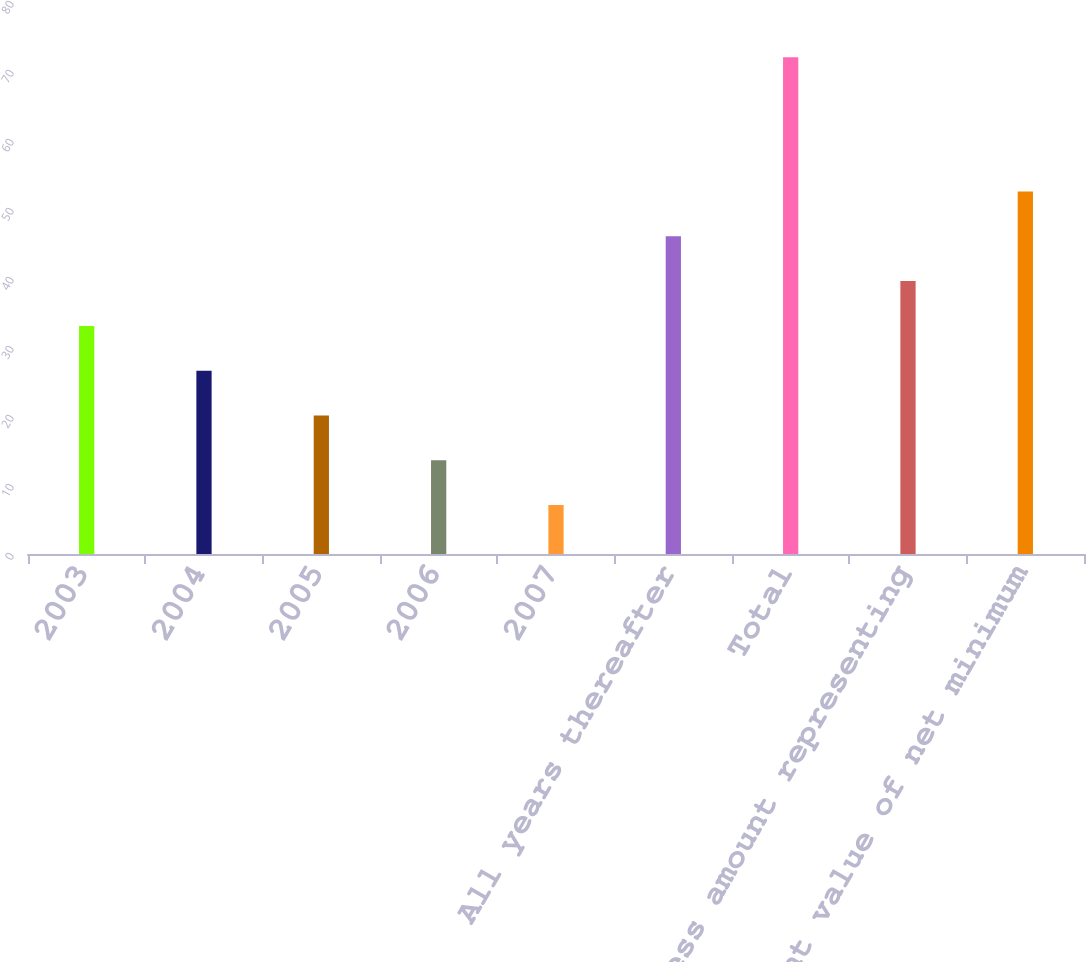Convert chart to OTSL. <chart><loc_0><loc_0><loc_500><loc_500><bar_chart><fcel>2003<fcel>2004<fcel>2005<fcel>2006<fcel>2007<fcel>All years thereafter<fcel>Total<fcel>Less amount representing<fcel>Present value of net minimum<nl><fcel>33.06<fcel>26.57<fcel>20.08<fcel>13.59<fcel>7.1<fcel>46.04<fcel>72<fcel>39.55<fcel>52.53<nl></chart> 